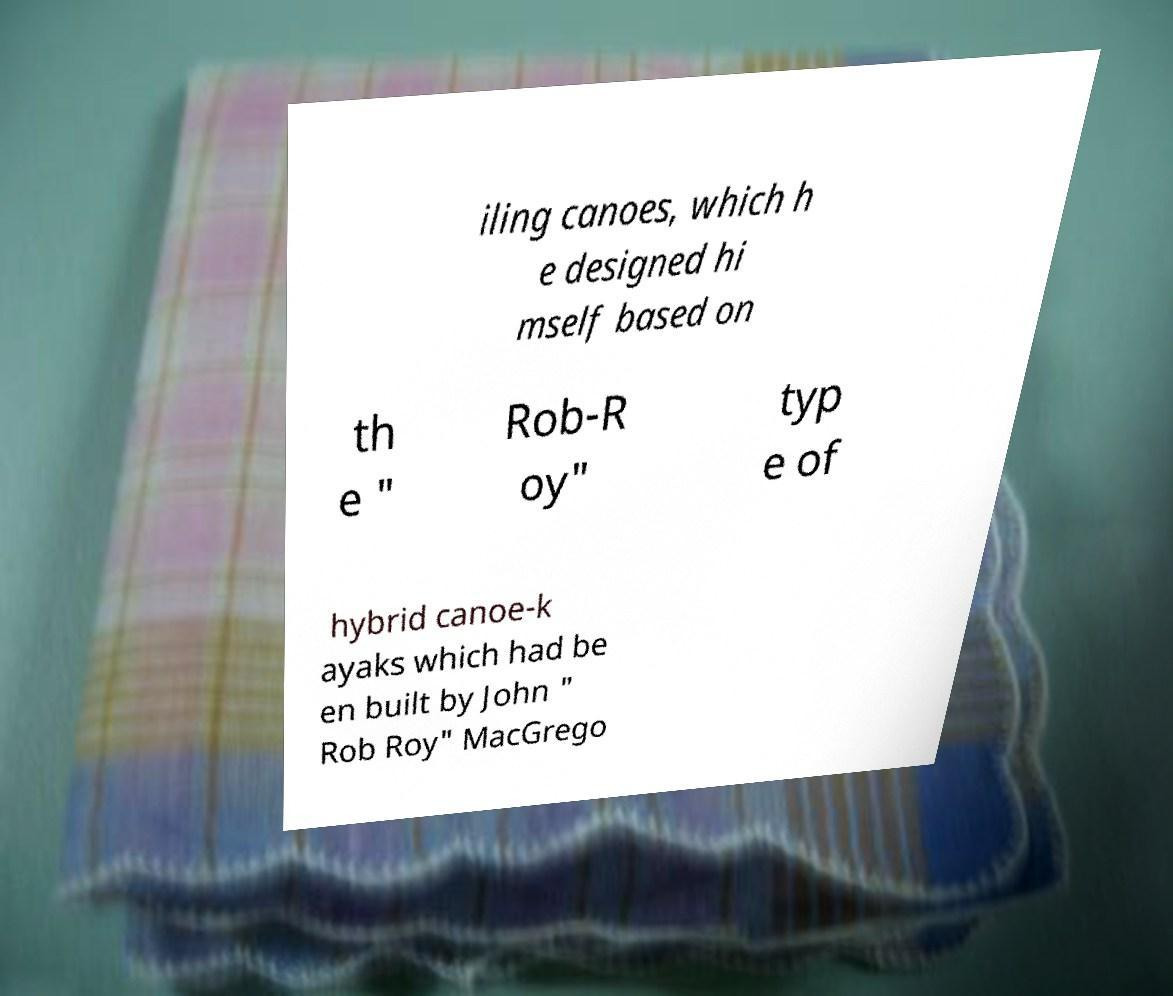Please identify and transcribe the text found in this image. iling canoes, which h e designed hi mself based on th e " Rob-R oy" typ e of hybrid canoe-k ayaks which had be en built by John " Rob Roy" MacGrego 